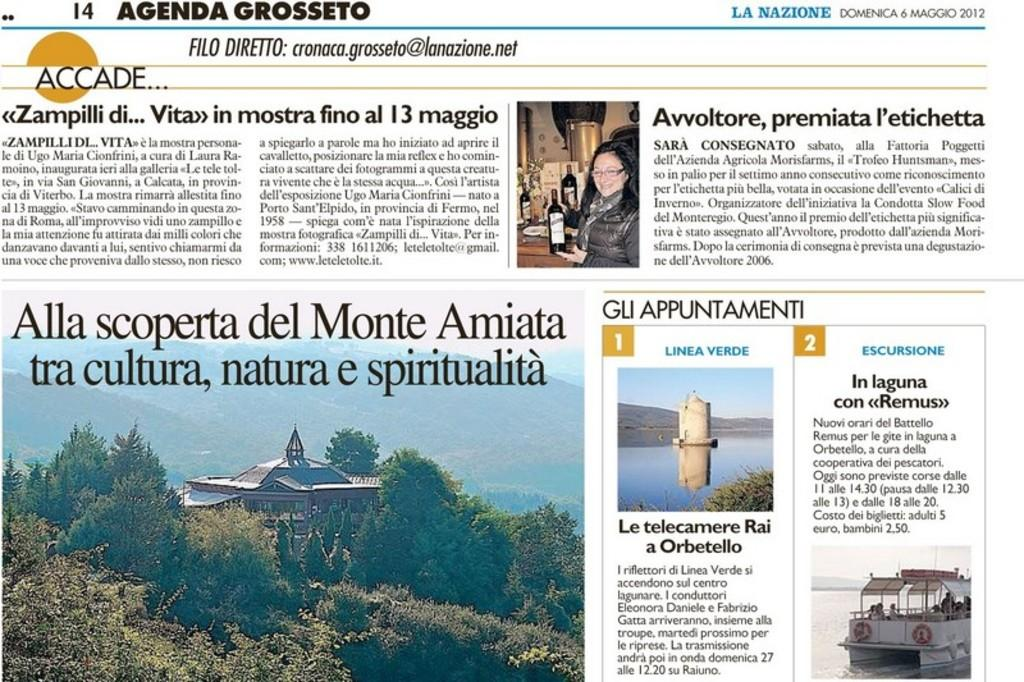<image>
Offer a succinct explanation of the picture presented. Agenda Grosseto shows photos and articles from the year 2012. 